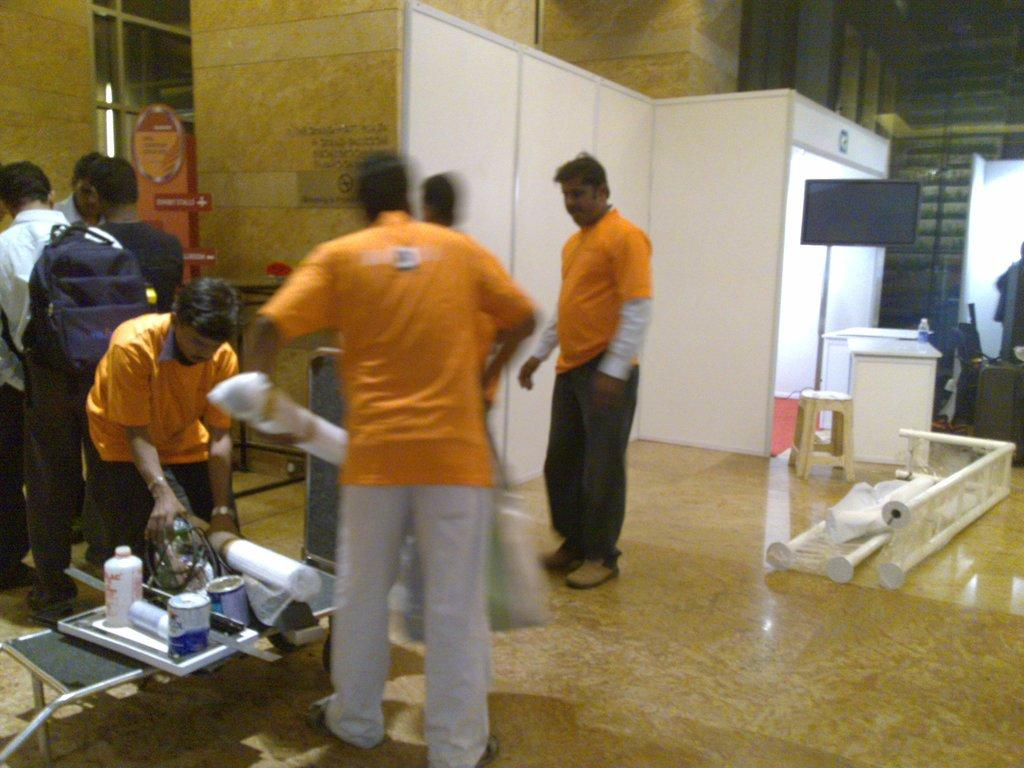What is the main subject of the image? The main subject of the image is a group of men. What are the men wearing? The men are wearing orange color t-shirts. What object can be seen on the right side of the image? There appears to be a refrigerator on the right side of the image. What feature does the refrigerator have? The refrigerator has lights. Are there any cherries on the refrigerator in the image? There is no mention of cherries in the image, and they are not visible in the provided facts. 